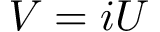Convert formula to latex. <formula><loc_0><loc_0><loc_500><loc_500>V = i U</formula> 